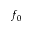Convert formula to latex. <formula><loc_0><loc_0><loc_500><loc_500>f _ { 0 }</formula> 